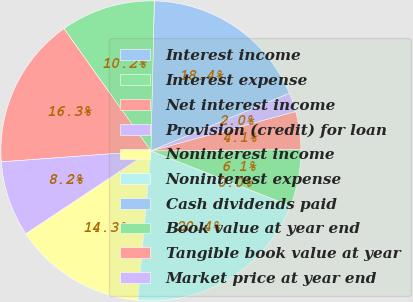Convert chart. <chart><loc_0><loc_0><loc_500><loc_500><pie_chart><fcel>Interest income<fcel>Interest expense<fcel>Net interest income<fcel>Provision (credit) for loan<fcel>Noninterest income<fcel>Noninterest expense<fcel>Cash dividends paid<fcel>Book value at year end<fcel>Tangible book value at year<fcel>Market price at year end<nl><fcel>18.37%<fcel>10.2%<fcel>16.33%<fcel>8.16%<fcel>14.29%<fcel>20.41%<fcel>0.0%<fcel>6.12%<fcel>4.08%<fcel>2.04%<nl></chart> 